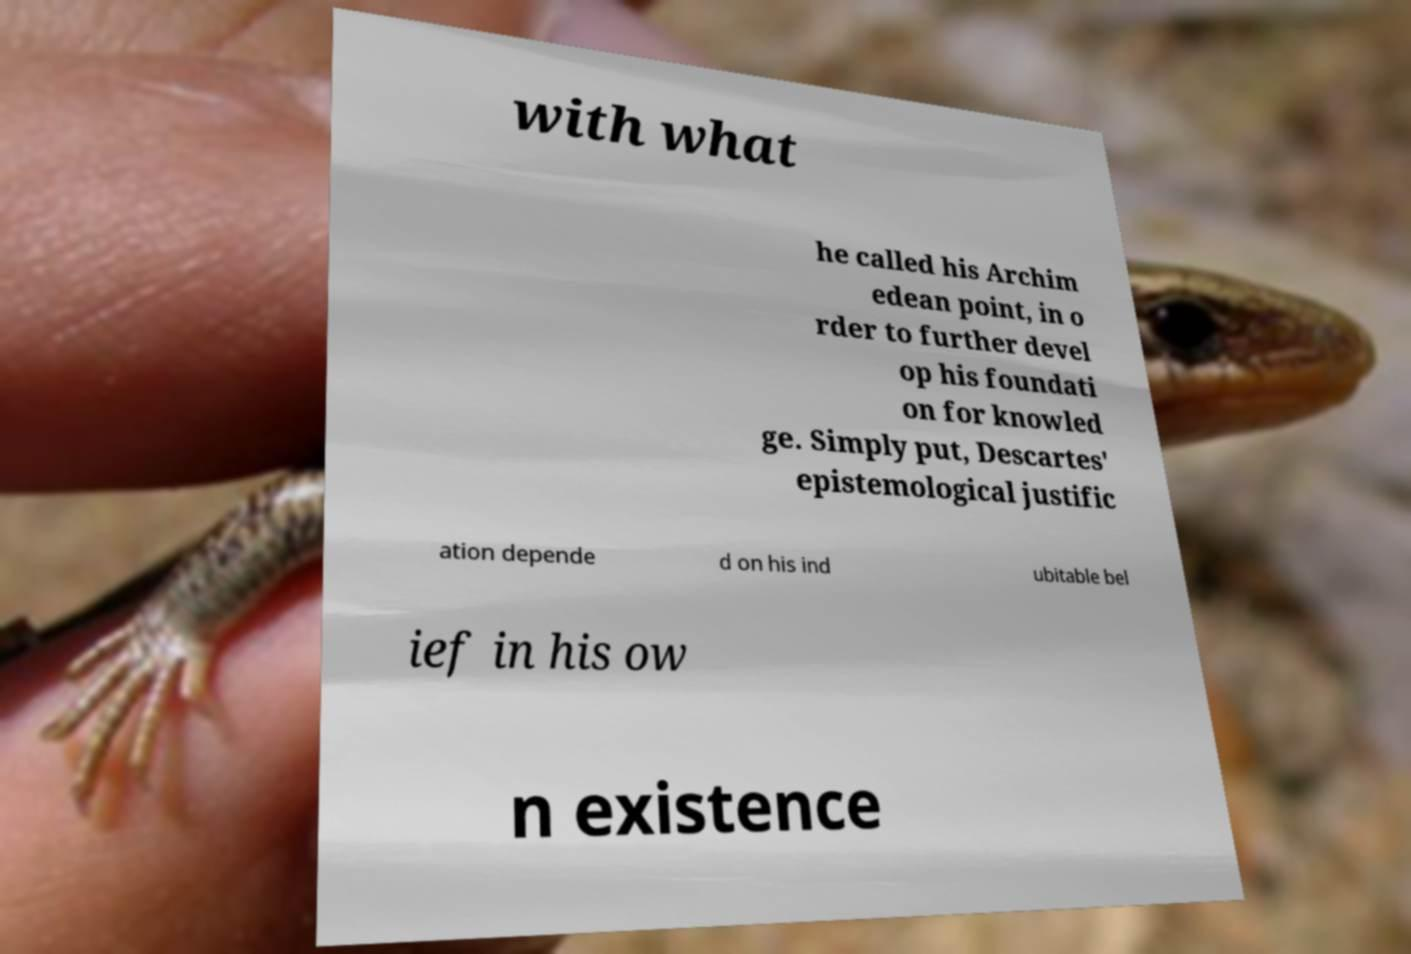Could you extract and type out the text from this image? with what he called his Archim edean point, in o rder to further devel op his foundati on for knowled ge. Simply put, Descartes' epistemological justific ation depende d on his ind ubitable bel ief in his ow n existence 